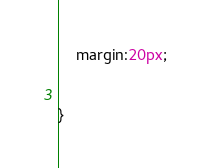<code> <loc_0><loc_0><loc_500><loc_500><_CSS_>    margin:20px;
 

}</code> 